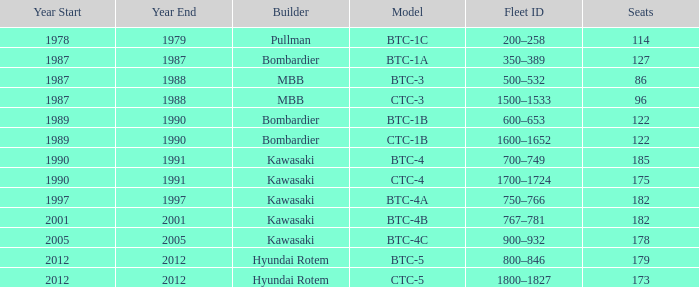How many seats does the BTC-5 model have? 179.0. 